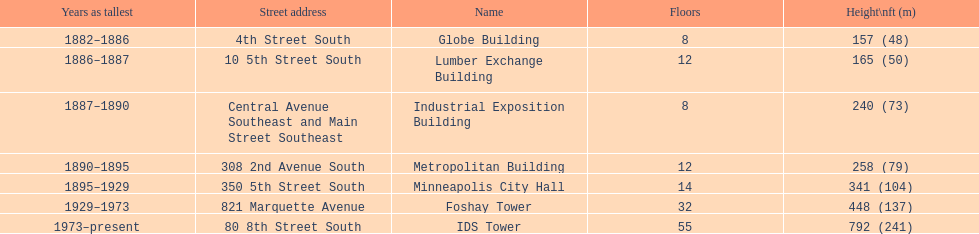How many floors does the foshay tower have? 32. 